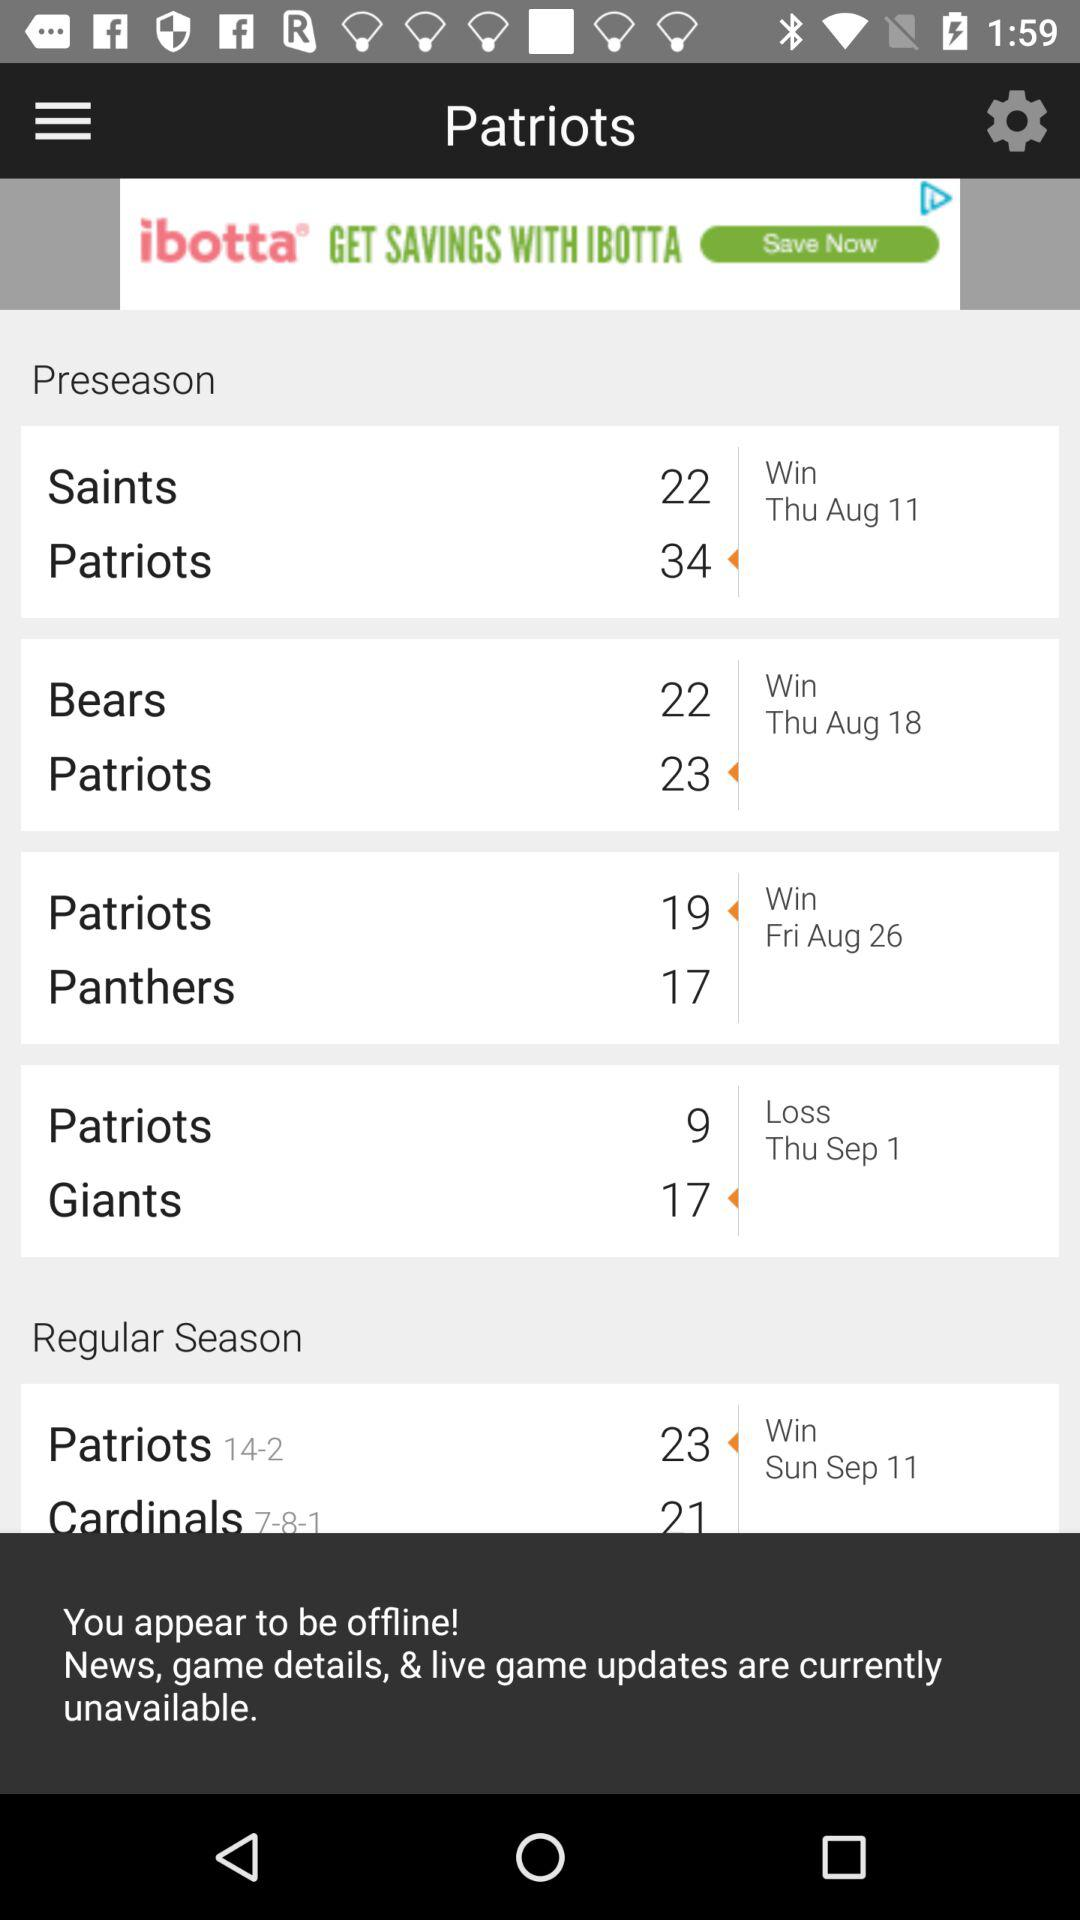Which teams are playing their regular season on September 11? The two teams, the "Patriots" and the "Cardinals", are playing their regular season on September 11. 